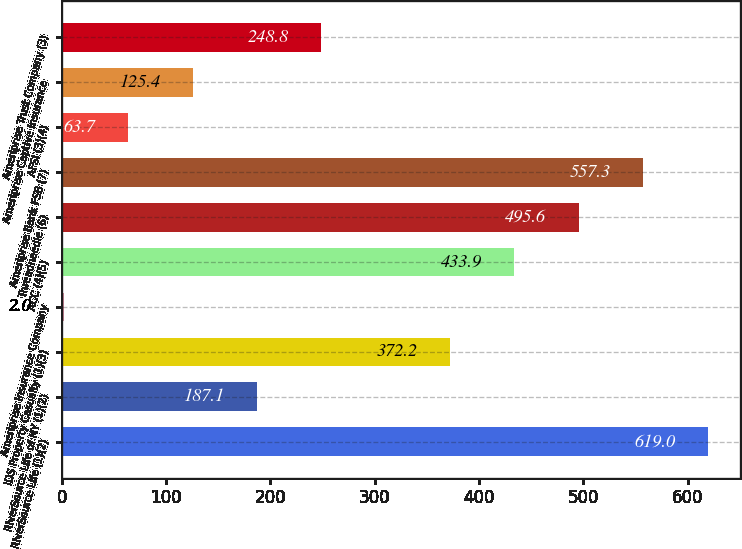Convert chart. <chart><loc_0><loc_0><loc_500><loc_500><bar_chart><fcel>RiverSource Life (1)(2)<fcel>RiverSource Life of NY (1)(2)<fcel>IDS Property Casualty (1)(3)<fcel>Ameriprise Insurance Company<fcel>ACC (4)(5)<fcel>Threadneedle (6)<fcel>Ameriprise Bank FSB (7)<fcel>AFSI (3)(4)<fcel>Ameriprise Captive Insurance<fcel>Ameriprise Trust Company (3)<nl><fcel>619<fcel>187.1<fcel>372.2<fcel>2<fcel>433.9<fcel>495.6<fcel>557.3<fcel>63.7<fcel>125.4<fcel>248.8<nl></chart> 